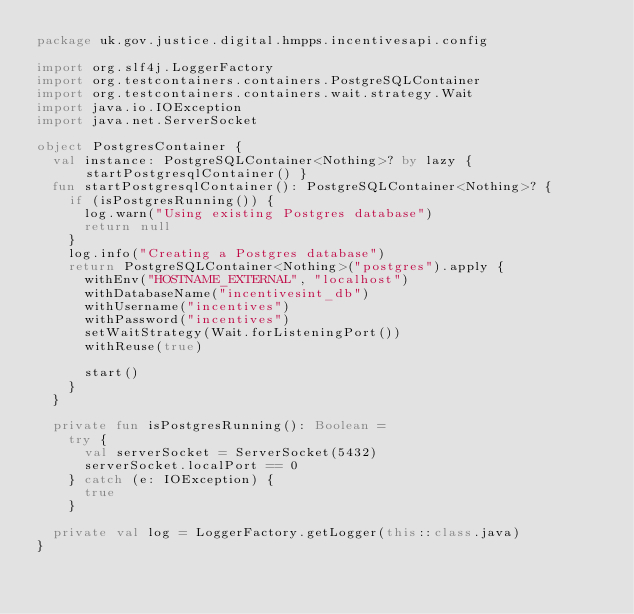Convert code to text. <code><loc_0><loc_0><loc_500><loc_500><_Kotlin_>package uk.gov.justice.digital.hmpps.incentivesapi.config

import org.slf4j.LoggerFactory
import org.testcontainers.containers.PostgreSQLContainer
import org.testcontainers.containers.wait.strategy.Wait
import java.io.IOException
import java.net.ServerSocket

object PostgresContainer {
  val instance: PostgreSQLContainer<Nothing>? by lazy { startPostgresqlContainer() }
  fun startPostgresqlContainer(): PostgreSQLContainer<Nothing>? {
    if (isPostgresRunning()) {
      log.warn("Using existing Postgres database")
      return null
    }
    log.info("Creating a Postgres database")
    return PostgreSQLContainer<Nothing>("postgres").apply {
      withEnv("HOSTNAME_EXTERNAL", "localhost")
      withDatabaseName("incentivesint_db")
      withUsername("incentives")
      withPassword("incentives")
      setWaitStrategy(Wait.forListeningPort())
      withReuse(true)

      start()
    }
  }

  private fun isPostgresRunning(): Boolean =
    try {
      val serverSocket = ServerSocket(5432)
      serverSocket.localPort == 0
    } catch (e: IOException) {
      true
    }

  private val log = LoggerFactory.getLogger(this::class.java)
}
</code> 